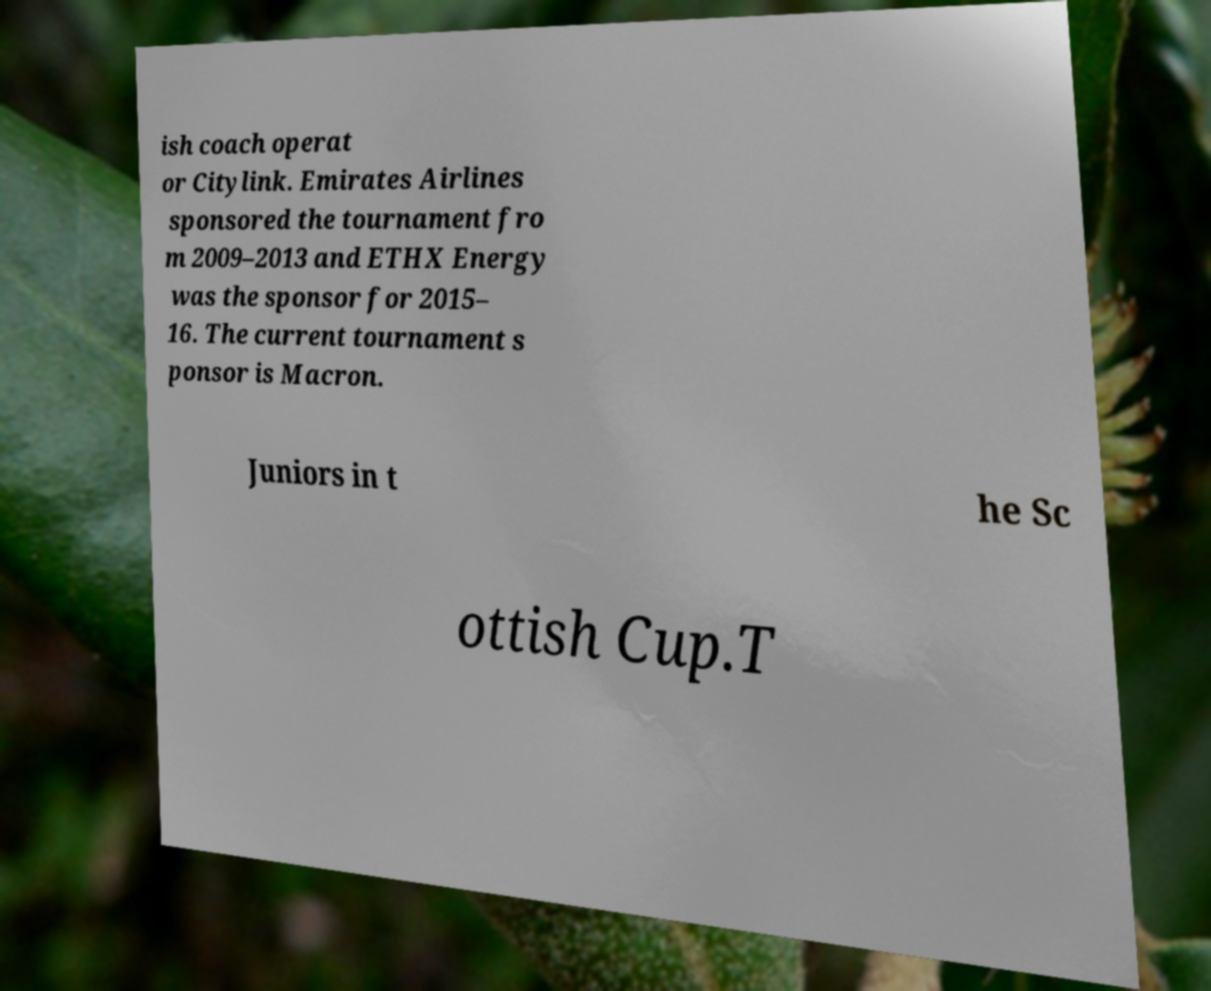What messages or text are displayed in this image? I need them in a readable, typed format. ish coach operat or Citylink. Emirates Airlines sponsored the tournament fro m 2009–2013 and ETHX Energy was the sponsor for 2015– 16. The current tournament s ponsor is Macron. Juniors in t he Sc ottish Cup.T 